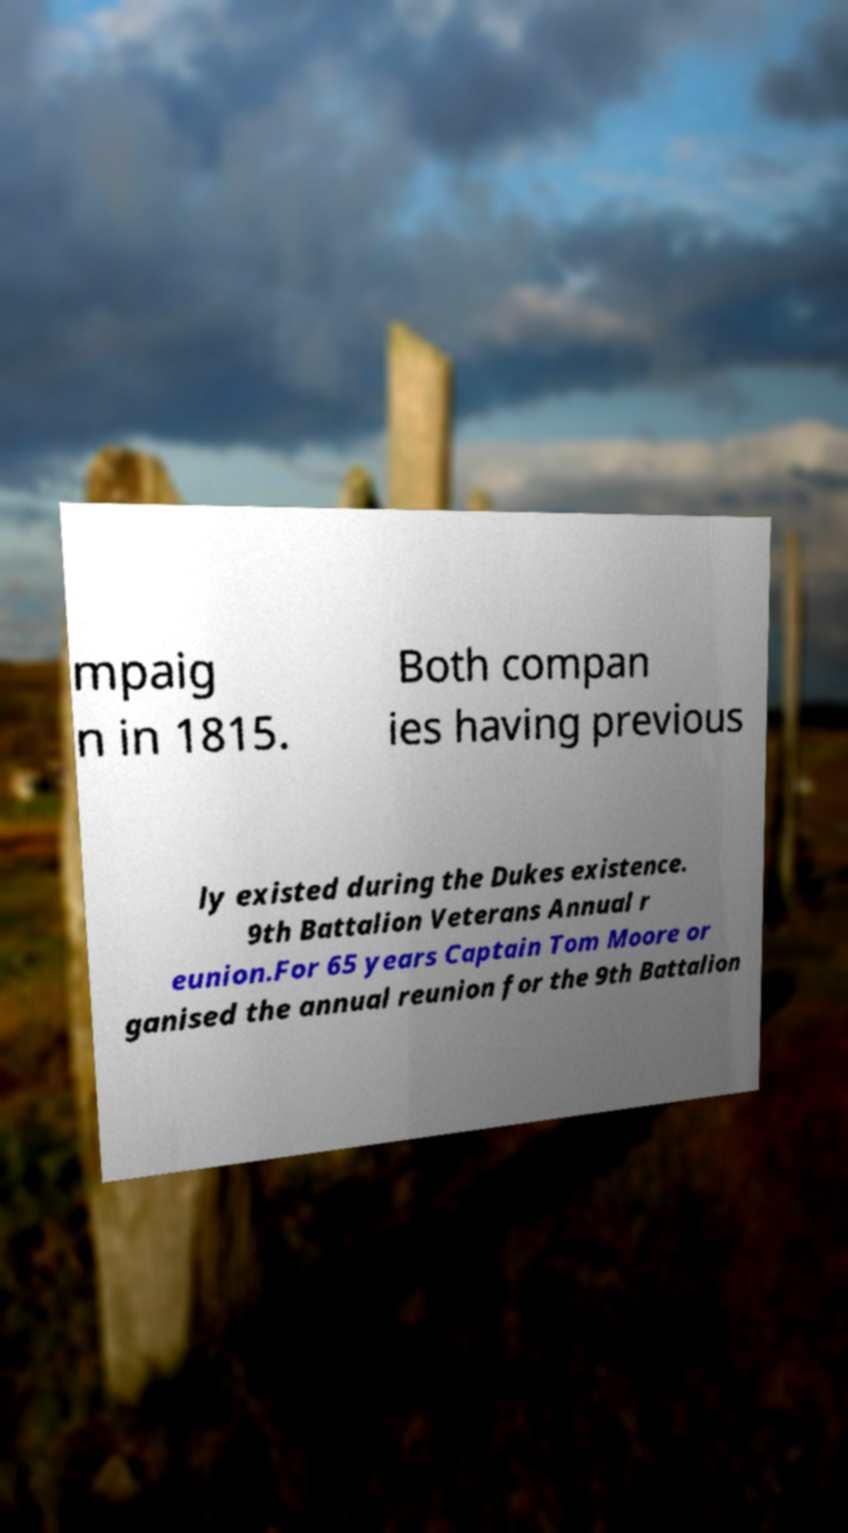Could you assist in decoding the text presented in this image and type it out clearly? mpaig n in 1815. Both compan ies having previous ly existed during the Dukes existence. 9th Battalion Veterans Annual r eunion.For 65 years Captain Tom Moore or ganised the annual reunion for the 9th Battalion 